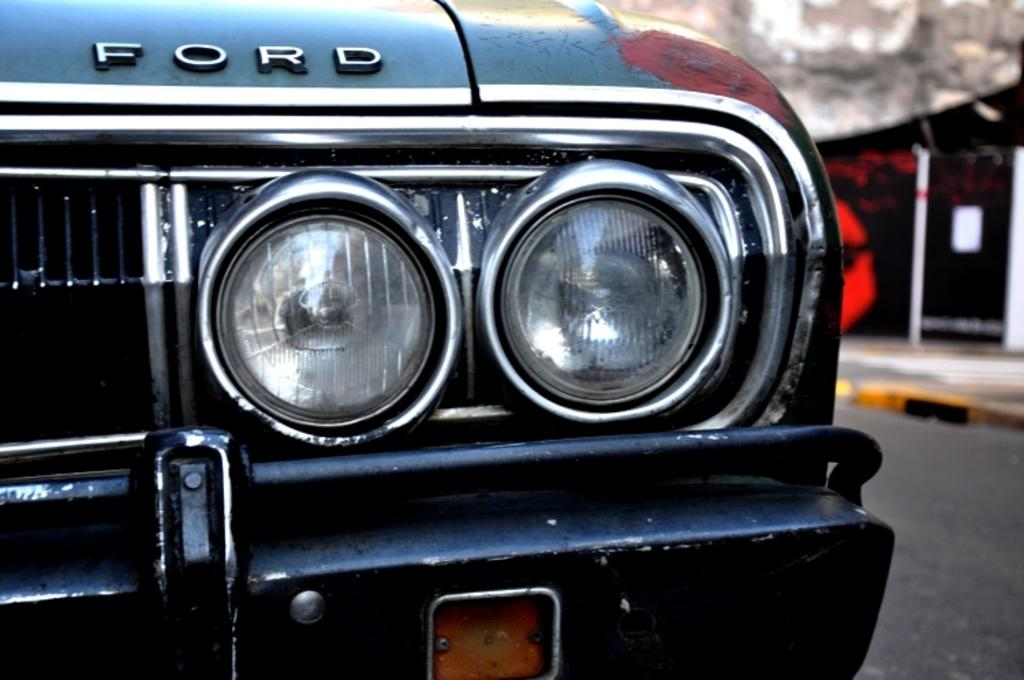What is the main subject of the picture? The main subject of the picture is a car. Can you describe the car's features? The car has two headlights in the middle and is black. How would you describe the background of the image? The background of the image is blurred. What type of mint can be seen growing near the car in the image? There is no mint present in the image; it only features a black car with two headlights in the middle. Is there a fire hydrant visible next to the car in the image? No, there is no fire hydrant present in the image. 